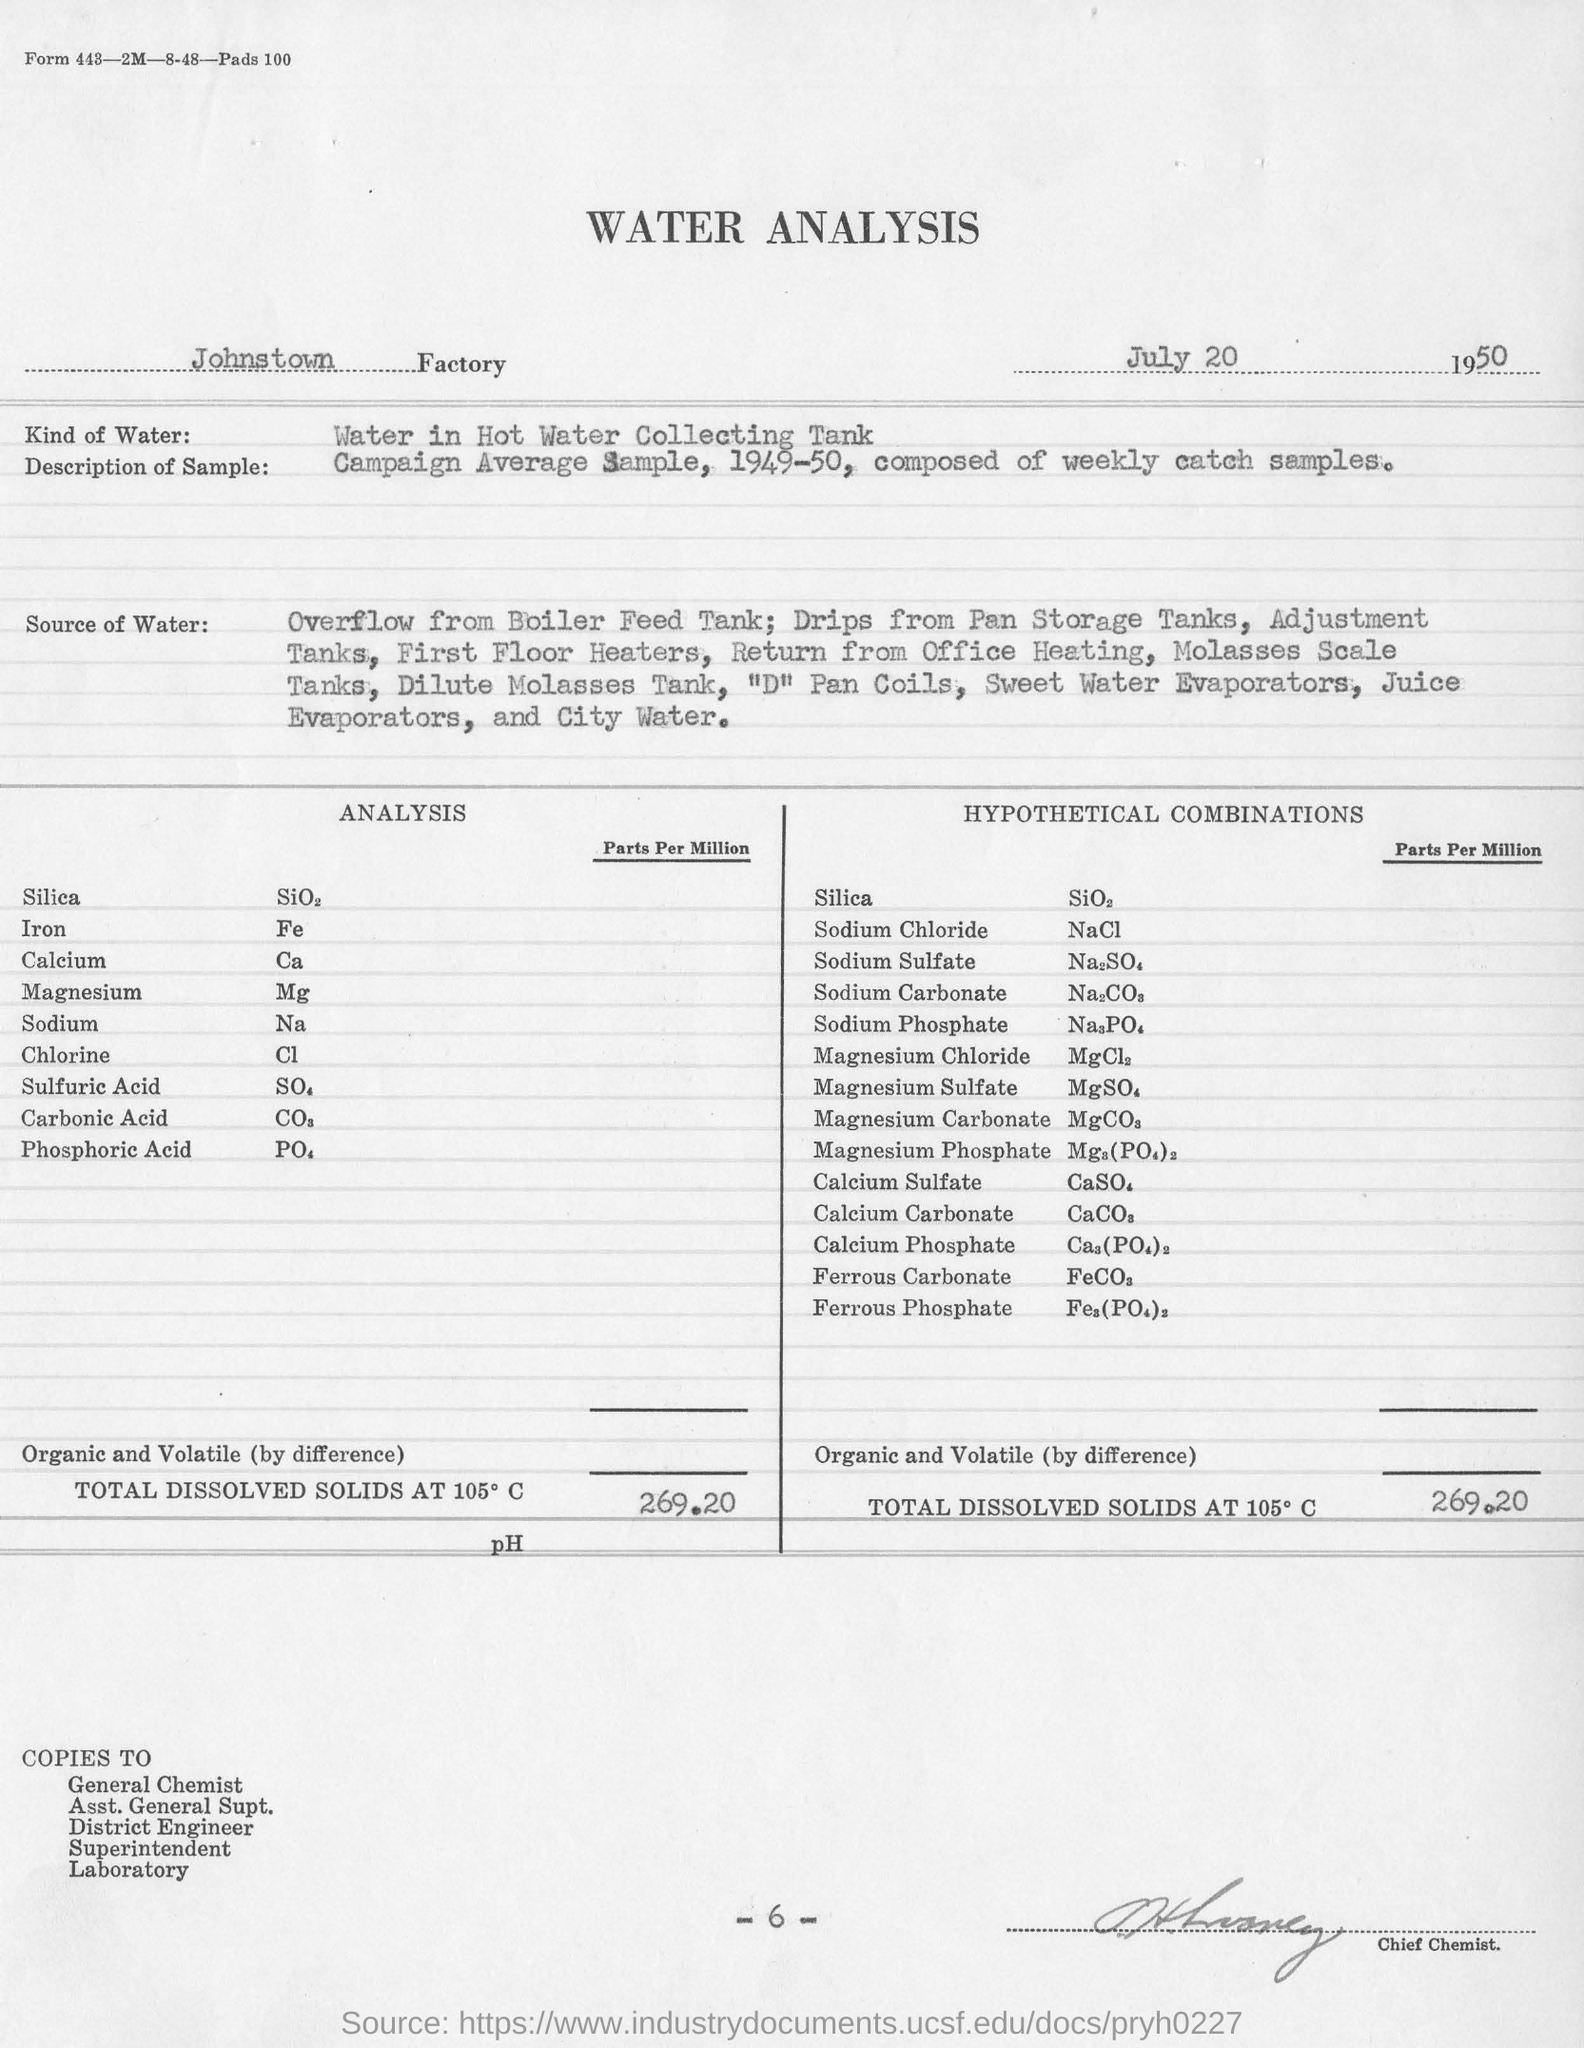Point out several critical features in this image. The sample taken is the Campaign Average Sample from 1949-50, which consists of weekly catch samples. Water from the hot water collecting tank is used for analysis in this experiment. The undersigned person is designated as the Chief Chemist. The analysis for the Johnstown factory was conducted at the Johnstown factory. 